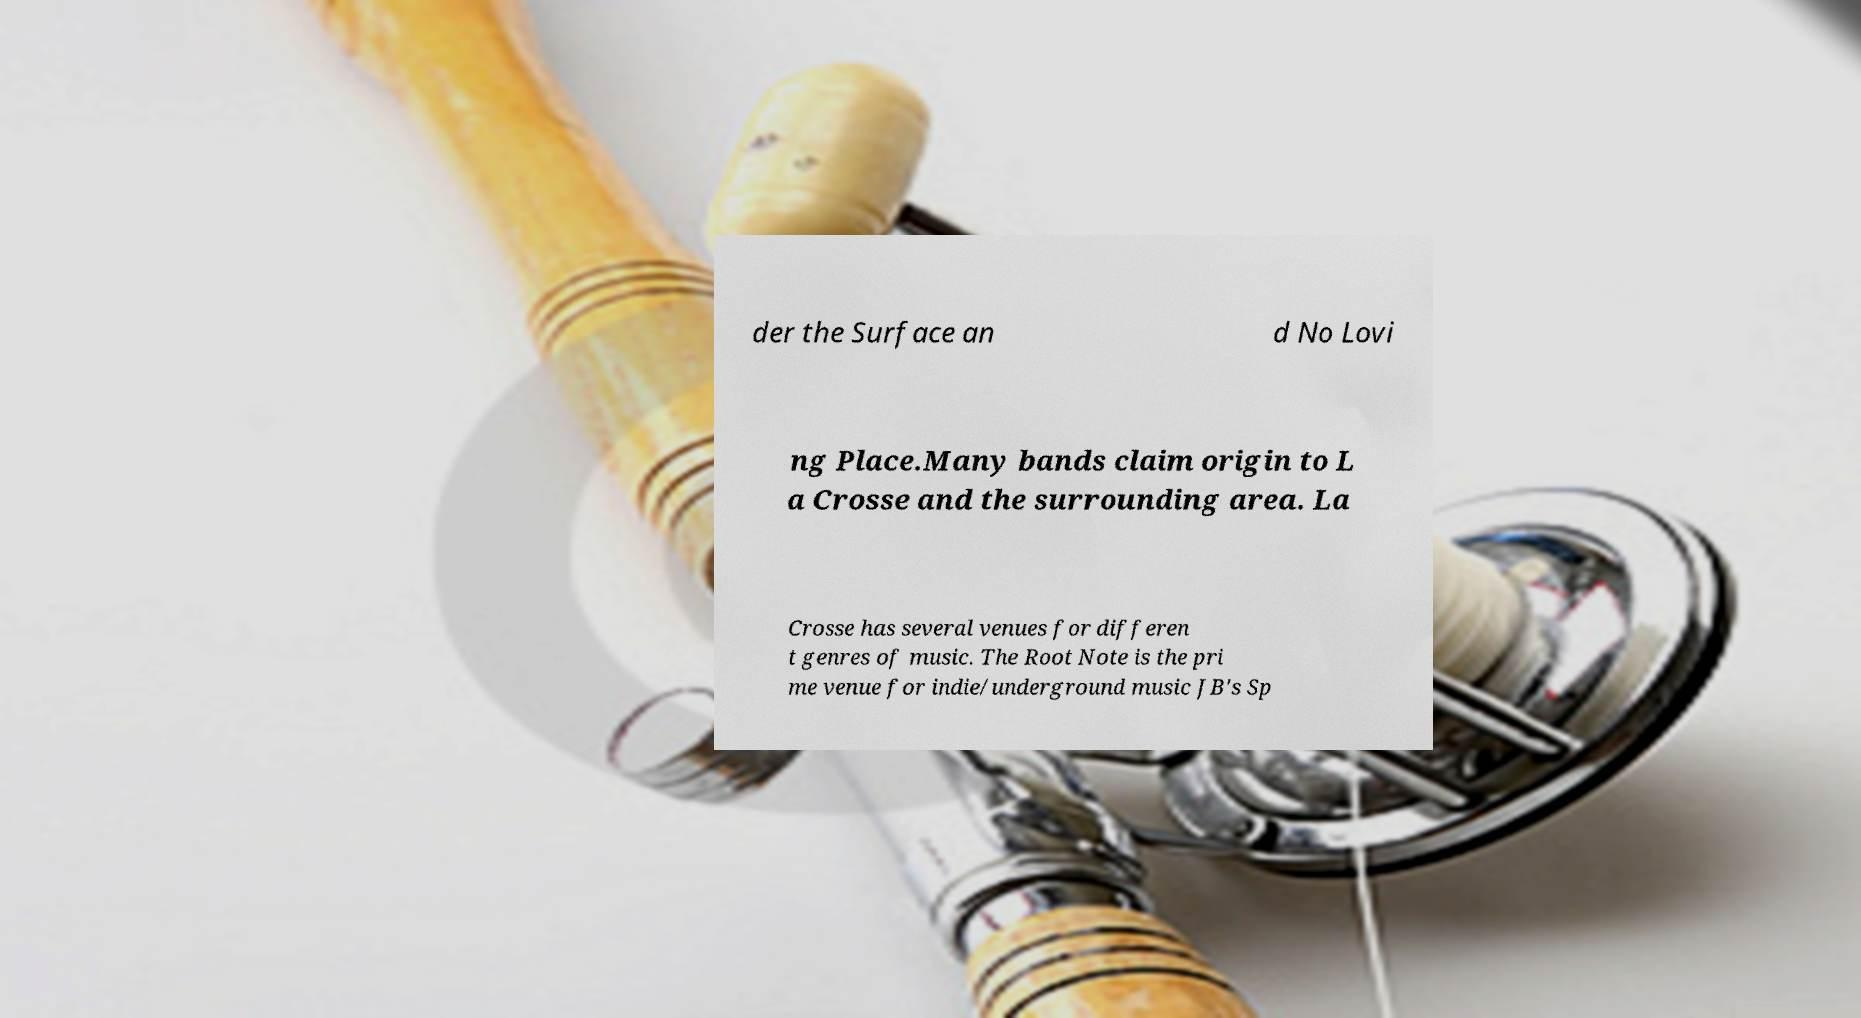What messages or text are displayed in this image? I need them in a readable, typed format. der the Surface an d No Lovi ng Place.Many bands claim origin to L a Crosse and the surrounding area. La Crosse has several venues for differen t genres of music. The Root Note is the pri me venue for indie/underground music JB's Sp 